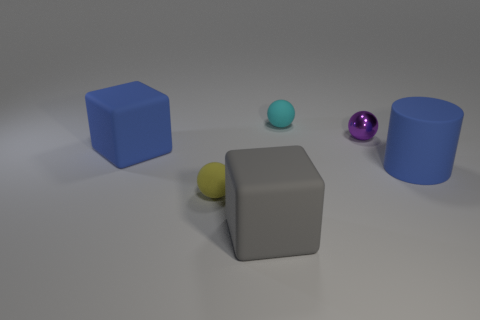How many rubber blocks are there?
Keep it short and to the point. 2. How many objects are either large purple cylinders or blue rubber cylinders that are on the right side of the gray rubber thing?
Provide a succinct answer. 1. Do the rubber sphere in front of the cyan object and the gray rubber object have the same size?
Keep it short and to the point. No. How many shiny things are either big yellow spheres or big blue blocks?
Offer a very short reply. 0. There is a block in front of the yellow rubber thing; what is its size?
Keep it short and to the point. Large. Does the yellow rubber object have the same shape as the big gray matte thing?
Make the answer very short. No. What number of small things are either shiny cylinders or metallic objects?
Your answer should be compact. 1. There is a large gray thing; are there any large blue rubber objects right of it?
Give a very brief answer. Yes. Are there the same number of rubber cylinders that are on the left side of the small cyan matte ball and blocks?
Your answer should be compact. No. What size is the purple metal thing that is the same shape as the cyan thing?
Your answer should be compact. Small. 